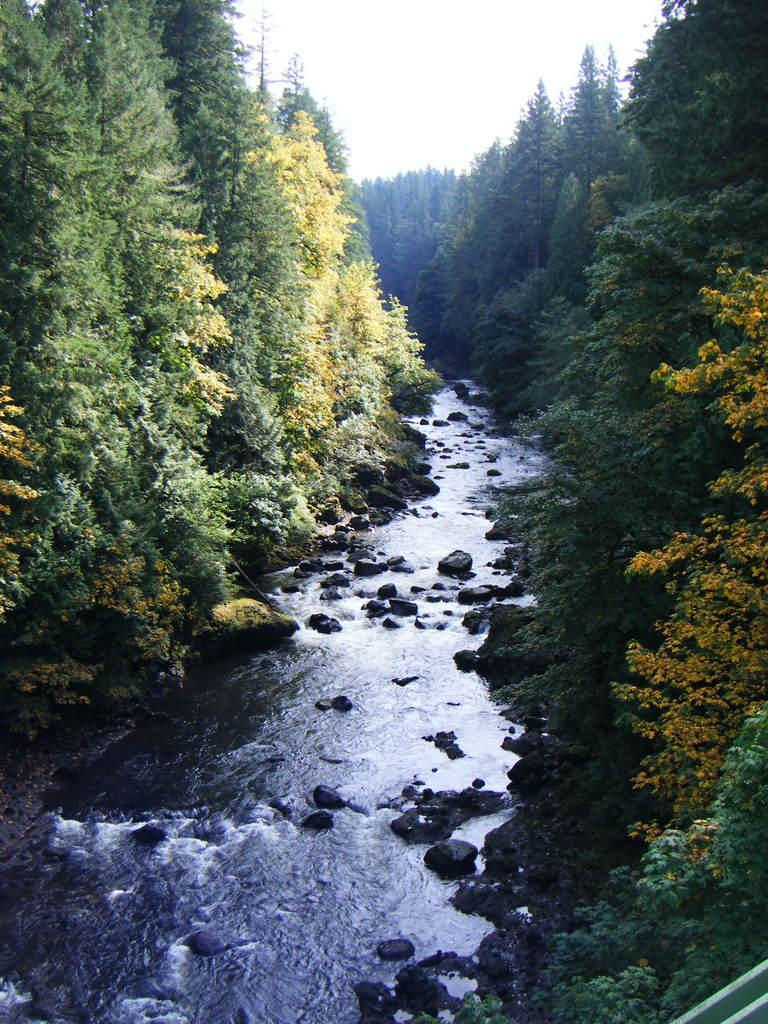What is the primary element visible in the image? There is water in the image. What other objects or features can be seen in the image? There are rocks and trees visible in the image. What can be seen in the background of the image? The sky is visible in the background of the image. What type of eggnog is being served in the park in the image? There is no eggnog or park present in the image; it features water, rocks, trees, and the sky. 